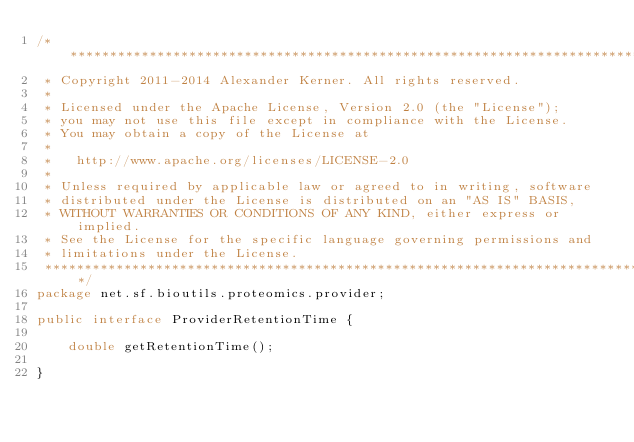<code> <loc_0><loc_0><loc_500><loc_500><_Java_>/*******************************************************************************
 * Copyright 2011-2014 Alexander Kerner. All rights reserved.
 * 
 * Licensed under the Apache License, Version 2.0 (the "License");
 * you may not use this file except in compliance with the License.
 * You may obtain a copy of the License at
 * 
 *   http://www.apache.org/licenses/LICENSE-2.0
 * 
 * Unless required by applicable law or agreed to in writing, software
 * distributed under the License is distributed on an "AS IS" BASIS,
 * WITHOUT WARRANTIES OR CONDITIONS OF ANY KIND, either express or implied.
 * See the License for the specific language governing permissions and
 * limitations under the License.
 ******************************************************************************/
package net.sf.bioutils.proteomics.provider;

public interface ProviderRetentionTime {

    double getRetentionTime();

}
</code> 